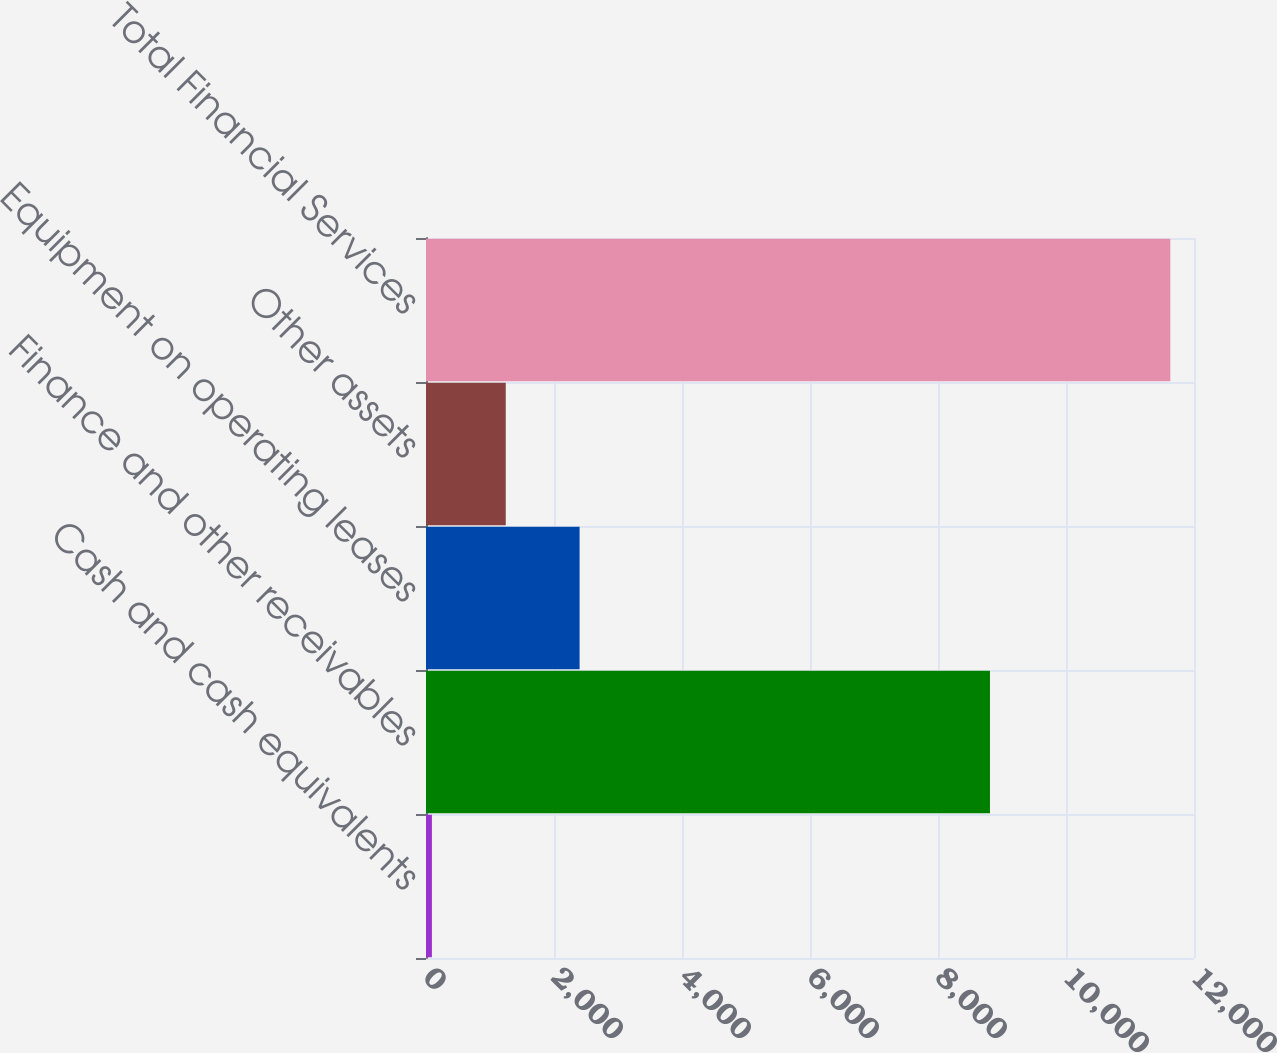<chart> <loc_0><loc_0><loc_500><loc_500><bar_chart><fcel>Cash and cash equivalents<fcel>Finance and other receivables<fcel>Equipment on operating leases<fcel>Other assets<fcel>Total Financial Services<nl><fcel>92.4<fcel>8812.1<fcel>2399.94<fcel>1246.17<fcel>11630.1<nl></chart> 